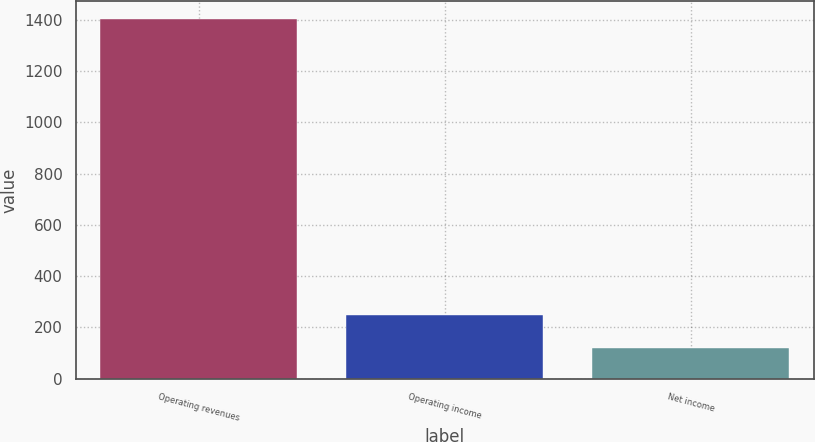Convert chart. <chart><loc_0><loc_0><loc_500><loc_500><bar_chart><fcel>Operating revenues<fcel>Operating income<fcel>Net income<nl><fcel>1401<fcel>248.1<fcel>120<nl></chart> 